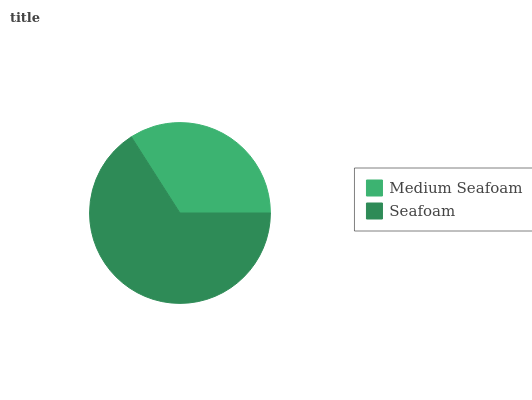Is Medium Seafoam the minimum?
Answer yes or no. Yes. Is Seafoam the maximum?
Answer yes or no. Yes. Is Seafoam the minimum?
Answer yes or no. No. Is Seafoam greater than Medium Seafoam?
Answer yes or no. Yes. Is Medium Seafoam less than Seafoam?
Answer yes or no. Yes. Is Medium Seafoam greater than Seafoam?
Answer yes or no. No. Is Seafoam less than Medium Seafoam?
Answer yes or no. No. Is Seafoam the high median?
Answer yes or no. Yes. Is Medium Seafoam the low median?
Answer yes or no. Yes. Is Medium Seafoam the high median?
Answer yes or no. No. Is Seafoam the low median?
Answer yes or no. No. 